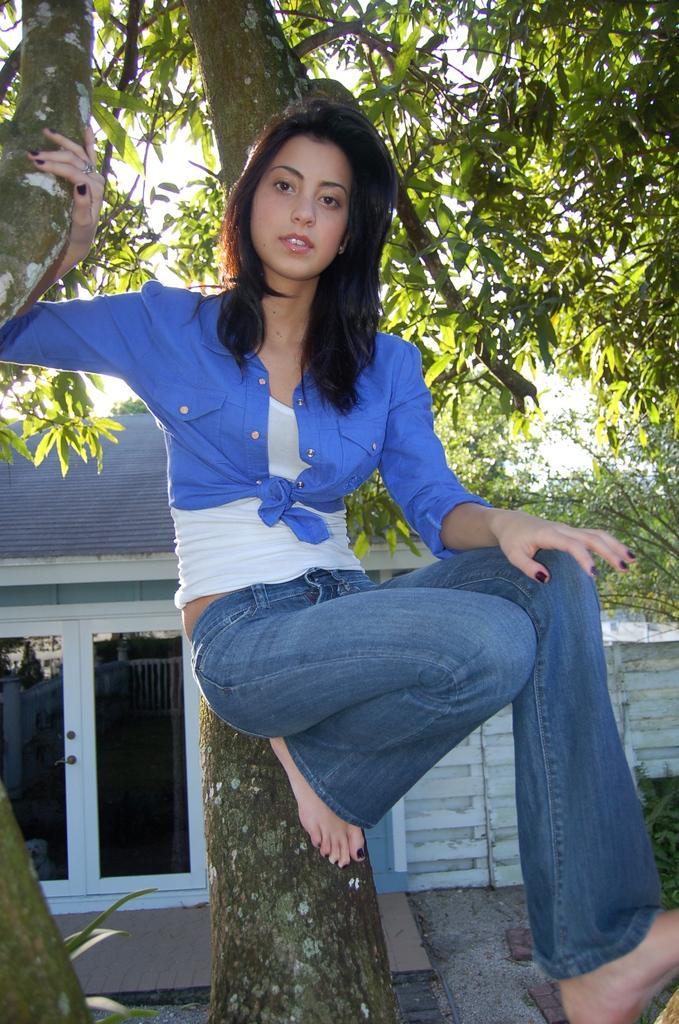Could you give a brief overview of what you see in this image? In this image, we can see a woman on the tree branch is watching. Background we can see house, glass doors, walkway, plants and tree. 